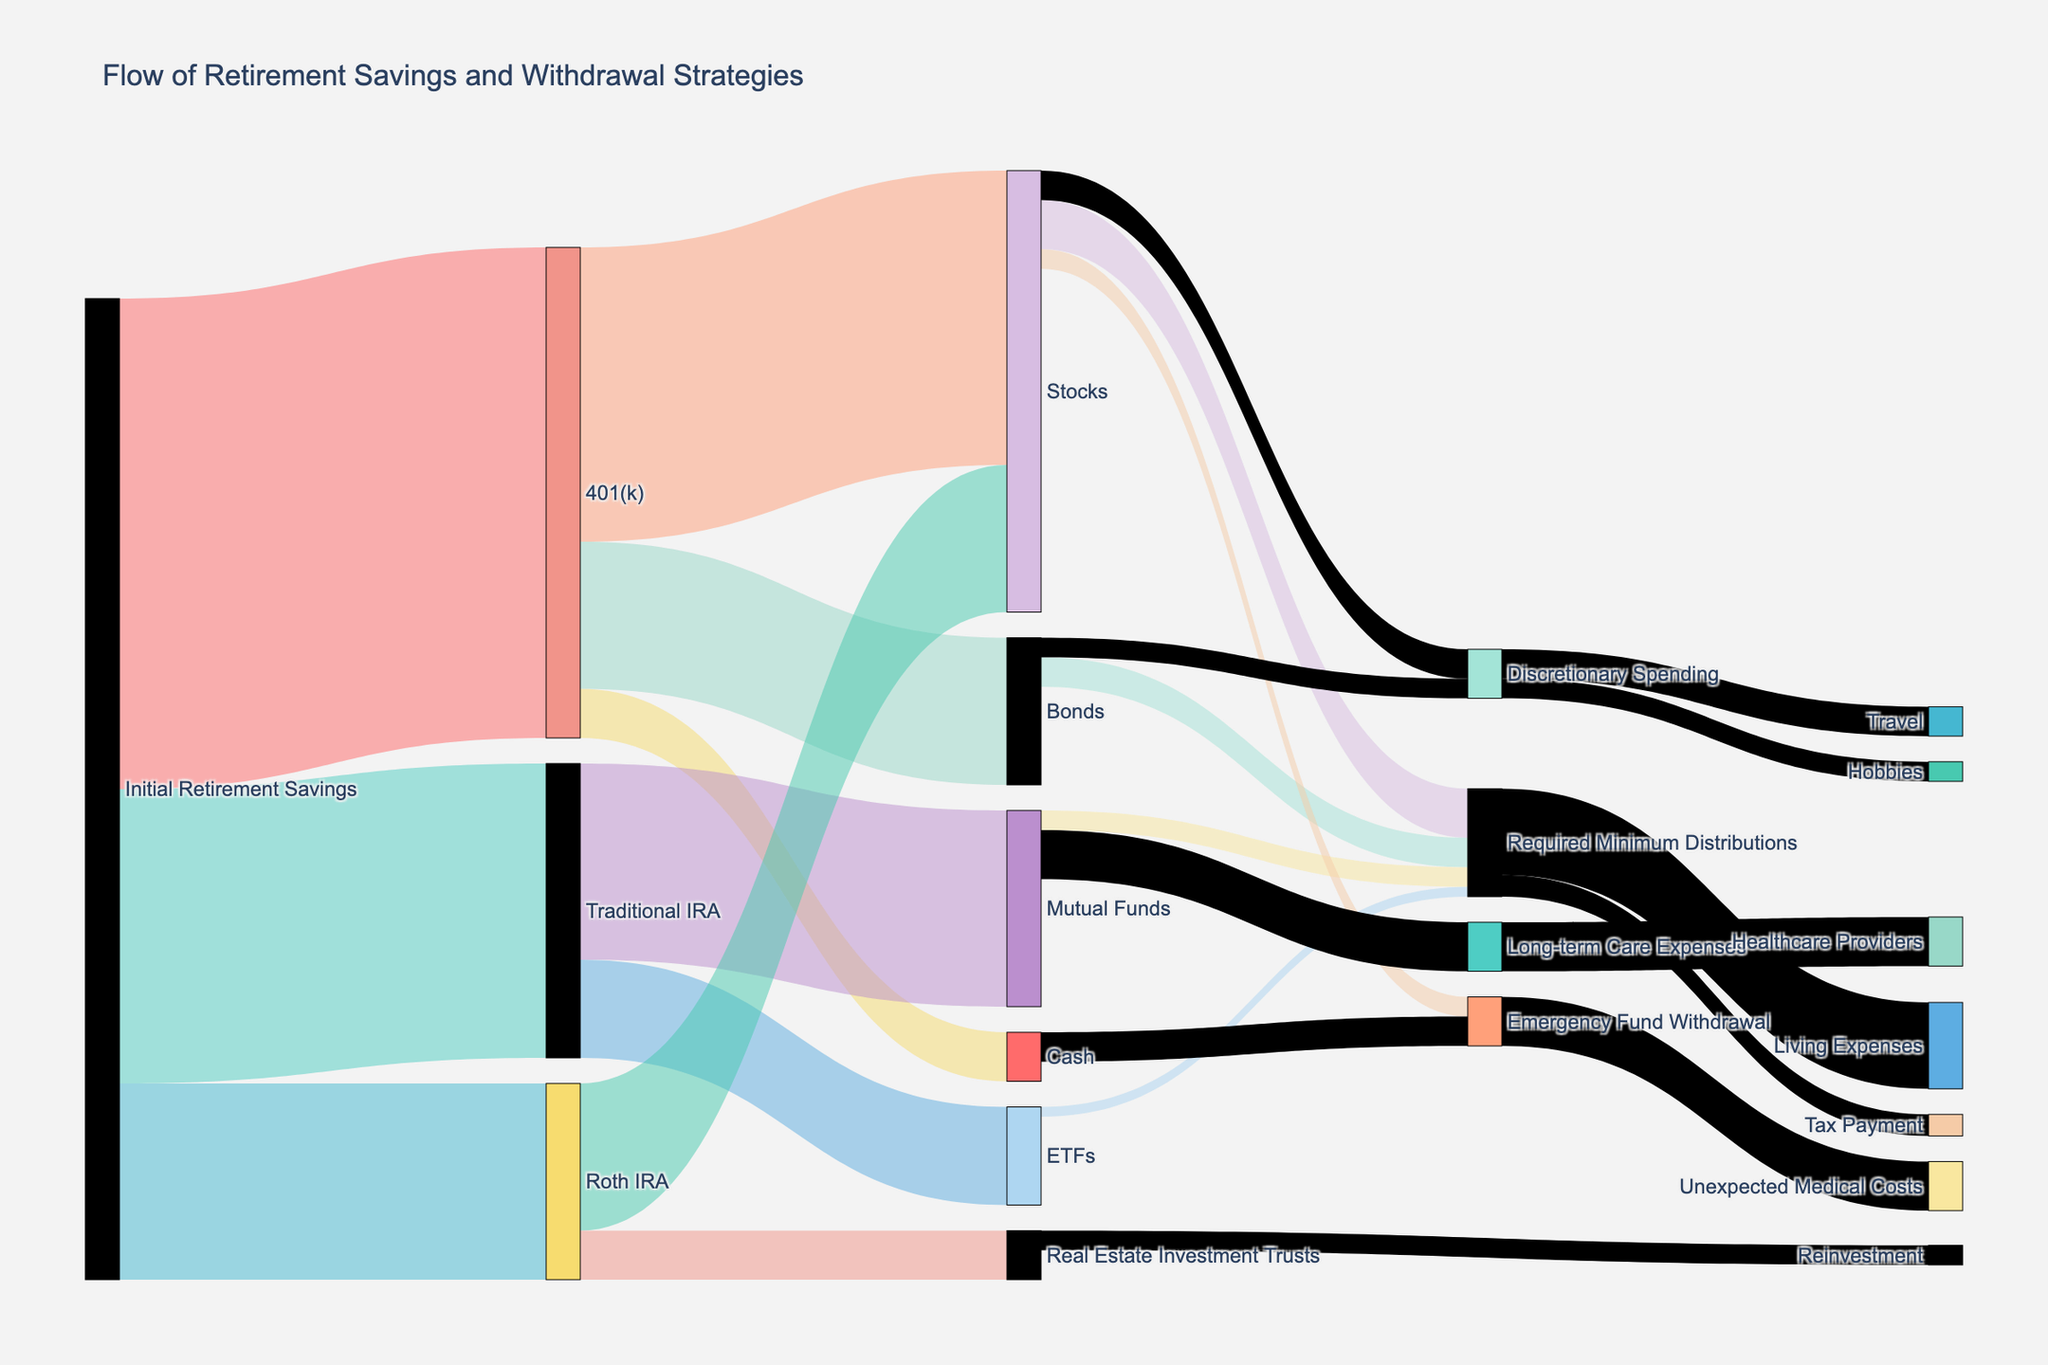How much of the initial retirement savings go into 401(k) accounts? First, look at the segment from "Initial Retirement Savings" to "401(k)" which shows a flow of 50,000. This value represents the portion of initial retirement savings allocated to 401(k) accounts.
Answer: 50,000 What is the total amount distributed to Required Minimum Distributions from various investment vehicles? Identify all flows leading to Required Minimum Distributions: 5,000 from Stocks, 3,000 from Bonds, 2,000 from Mutual Funds, and 1,000 from ETFs. Sum these values: 5,000 + 3,000 + 2,000 + 1,000 = 11,000.
Answer: 11,000 Compare the amount invested in Stocks from the 401(k) and the Roth IRA. Which one is higher? Check the flows from 401(k) to Stocks (30,000) and from Roth IRA to Stocks (15,000). 30,000 is greater than 15,000, so the amount invested in Stocks from 401(k) is higher.
Answer: 401(k) How much of the Emergency Fund Withdrawal is used for Unexpected Medical Costs? Identify the flow from Emergency Fund Withdrawal to Unexpected Medical Costs, which shows a value of 5,000.
Answer: 5,000 Which investment vehicle has the smallest flow into Required Minimum Distributions? Look at the flows into Required Minimum Distributions: 5,000 from Stocks, 3,000 from Bonds, 2,000 from Mutual Funds, and 1,000 from ETFs. The smallest value is 1,000 from ETFs.
Answer: ETFs How much is allocated to Discretionary Spending from Bonds and Stocks combined? Identify the flows from Bonds to Discretionary Spending (2,000) and from Stocks to Discretionary Spending (3,000). Sum these values: 2,000 + 3,000 = 5,000.
Answer: 5,000 How much is the total flow into Mutual Funds from both initial retirement savings and withdrawals? Check the flow into Mutual Funds: 20,000 from Traditional IRA (initial retirement savings). There is no flow from withdrawals into Mutual Funds.
Answer: 20,000 